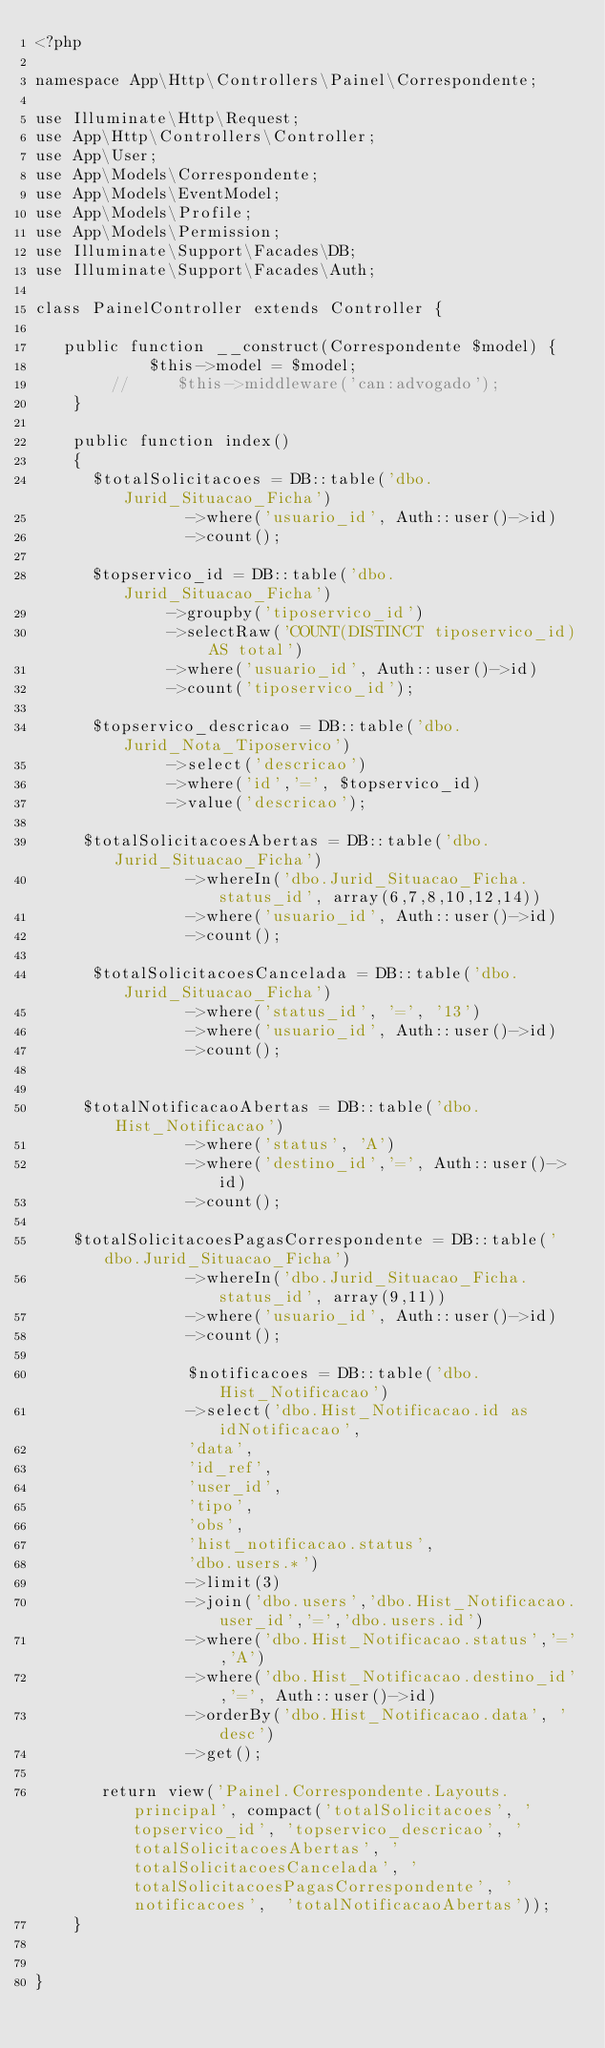<code> <loc_0><loc_0><loc_500><loc_500><_PHP_><?php

namespace App\Http\Controllers\Painel\Correspondente;

use Illuminate\Http\Request;
use App\Http\Controllers\Controller;
use App\User;
use App\Models\Correspondente;
use App\Models\EventModel;
use App\Models\Profile;
use App\Models\Permission;
use Illuminate\Support\Facades\DB;
use Illuminate\Support\Facades\Auth;

class PainelController extends Controller {

   public function __construct(Correspondente $model) {
            $this->model = $model;
        //     $this->middleware('can:advogado');
    }    

    public function index()
    {
      $totalSolicitacoes = DB::table('dbo.Jurid_Situacao_Ficha')
                ->where('usuario_id', Auth::user()->id)
                ->count();
            
      $topservico_id = DB::table('dbo.Jurid_Situacao_Ficha')
              ->groupby('tiposervico_id')
              ->selectRaw('COUNT(DISTINCT tiposervico_id) AS total')
              ->where('usuario_id', Auth::user()->id)
              ->count('tiposervico_id');
      
      $topservico_descricao = DB::table('dbo.Jurid_Nota_Tiposervico')
              ->select('descricao')
              ->where('id','=', $topservico_id)
              ->value('descricao'); 

     $totalSolicitacoesAbertas = DB::table('dbo.Jurid_Situacao_Ficha')
                ->whereIn('dbo.Jurid_Situacao_Ficha.status_id', array(6,7,8,10,12,14))
                ->where('usuario_id', Auth::user()->id)
                ->count();         
        
      $totalSolicitacoesCancelada = DB::table('dbo.Jurid_Situacao_Ficha')
                ->where('status_id', '=', '13')
                ->where('usuario_id', Auth::user()->id)
                ->count();
        
        
     $totalNotificacaoAbertas = DB::table('dbo.Hist_Notificacao')
                ->where('status', 'A')
                ->where('destino_id','=', Auth::user()->id)
                ->count();
       
    $totalSolicitacoesPagasCorrespondente = DB::table('dbo.Jurid_Situacao_Ficha')
                ->whereIn('dbo.Jurid_Situacao_Ficha.status_id', array(9,11))
                ->where('usuario_id', Auth::user()->id)
                ->count();  

                $notificacoes = DB::table('dbo.Hist_Notificacao')
                ->select('dbo.Hist_Notificacao.id as idNotificacao', 
                'data',
                'id_ref', 
                'user_id',
                'tipo', 
                'obs',
                'hist_notificacao.status', 
                'dbo.users.*')  
                ->limit(3)
                ->join('dbo.users','dbo.Hist_Notificacao.user_id','=','dbo.users.id')
                ->where('dbo.Hist_Notificacao.status','=','A')
                ->where('dbo.Hist_Notificacao.destino_id','=', Auth::user()->id)
                ->orderBy('dbo.Hist_Notificacao.data', 'desc')
                ->get();
               
       return view('Painel.Correspondente.Layouts.principal', compact('totalSolicitacoes', 'topservico_id', 'topservico_descricao', 'totalSolicitacoesAbertas', 'totalSolicitacoesCancelada', 'totalSolicitacoesPagasCorrespondente', 'notificacoes',  'totalNotificacaoAbertas'));
    }

  
}</code> 